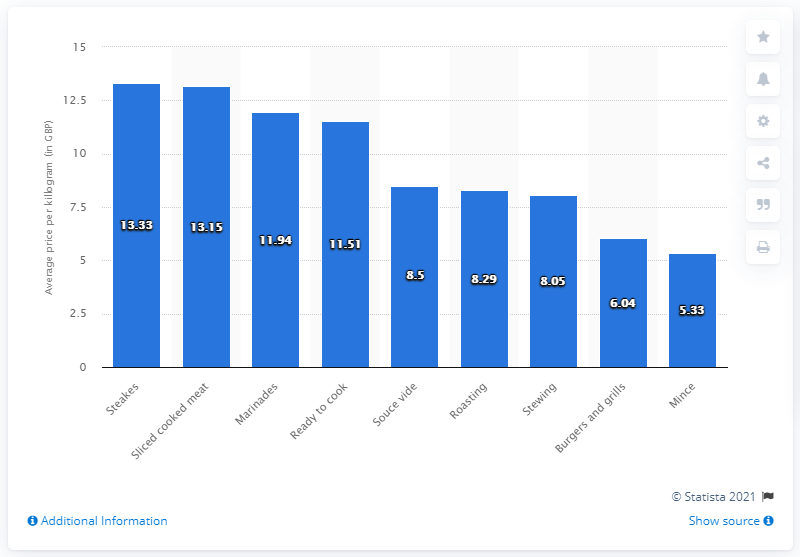Outline some significant characteristics in this image. The average price per kilogram of beef is approximately 13.33 pounds. 